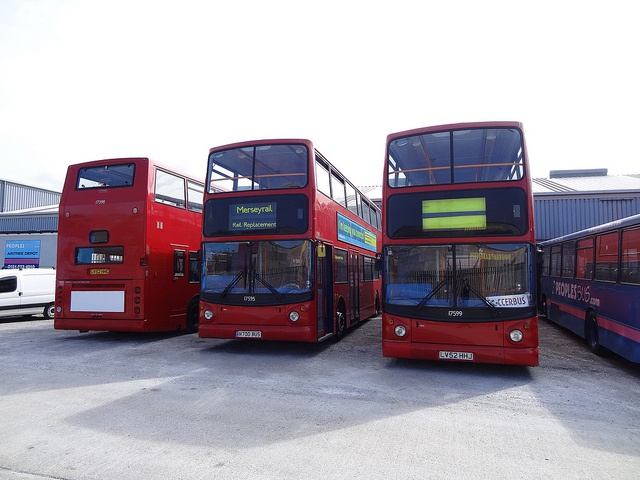Describe the objects in this image and their specific colors. I can see bus in white, black, maroon, gray, and navy tones, bus in white, black, maroon, gray, and navy tones, bus in white, maroon, black, and brown tones, bus in white, black, navy, maroon, and purple tones, and truck in white, black, darkgray, and gray tones in this image. 